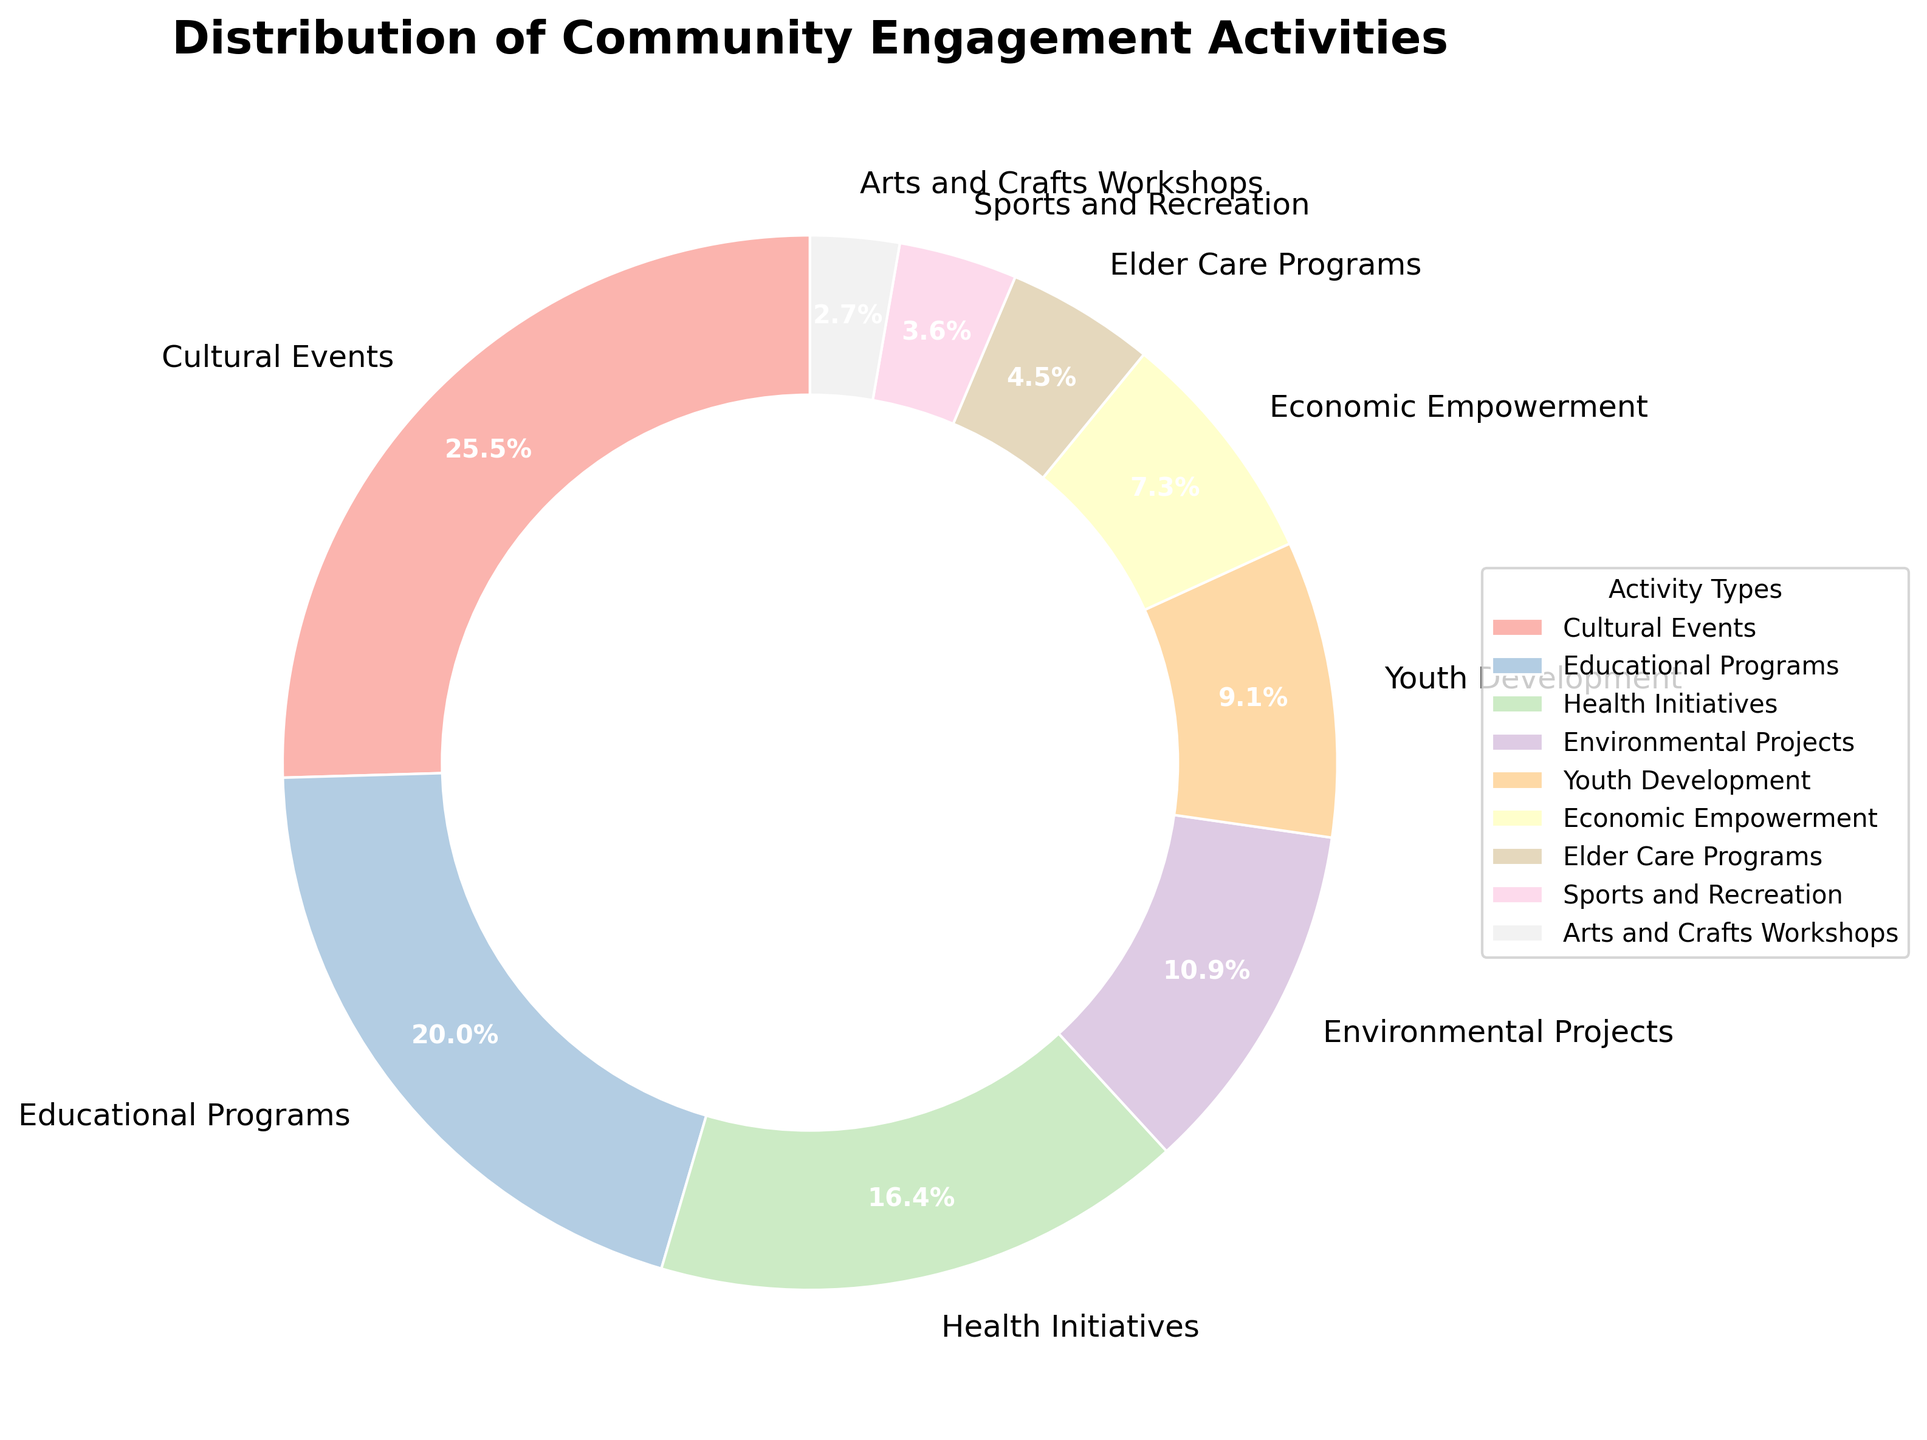What activity type has the biggest slice in the pie chart? Look for the activity type with the largest slice in the pie chart. The largest slice is labeled "Cultural Events" with 28%.
Answer: Cultural Events Can you identify which section represents 22% of the activities? Check the labels on the pie chart and find the one that shows 22%. The label for 22% is "Educational Programs."
Answer: Educational Programs What is the combined percentage of Health Initiatives and Environmental Projects? Add the percentages for Health Initiatives (18%) and Environmental Projects (12%). 18 + 12 = 30%
Answer: 30% Are Cultural Events more prevalent than Educational Programs? Compare the percentages of Cultural Events (28%) and Educational Programs (22%). Since 28% is more than 22%, Cultural Events are more prevalent.
Answer: Yes Which activity has the smallest representation in the pie chart? Look for the activity with the smallest slice in the pie chart. The smallest slice is labeled "Arts and Crafts Workshops" with 3%.
Answer: Arts and Crafts Workshops How do Youth Development and Economic Empowerment percentages compare? Compare the percentages of Youth Development (10%) and Economic Empowerment (8%). Youth Development with 10% has a larger percentage than Economic Empowerment with 8%.
Answer: Youth Development If you combine the percentages of Elder Care Programs and Sports and Recreation, does it cover more than 5%? Add the percentages for Elder Care Programs (5%) and Sports and Recreation (4%). 5 + 4 = 9%, which is greater than 5%.
Answer: Yes Among the types, which two activities together cover exactly 30% of the pie chart? Identify pair sums in the chart equal to 30%. Environmental Projects (12%) plus Youth Development (10%) plus Arts and Crafts Workshops (3%) plus Sports and Recreation (4%) equals 30%.
Answer: Environmental Projects & Youth Development, or Youth Development & Economic Empowerment What percentage of activities is devoted to Arts and Crafts Workshops compared to Sports and Recreation? Compare the percentages of Arts and Crafts Workshops (3%) and Sports and Recreation (4%). 4% is greater than 3%.
Answer: Sports and Recreation What is the total percentage of activities dedicated to Economic Empowerment, Elder Care Programs, and Sports and Recreation combined? Add the percentages for Economic Empowerment (8%), Elder Care Programs (5%), and Sports and Recreation (4%). 8 + 5 + 4 = 17%
Answer: 17% 